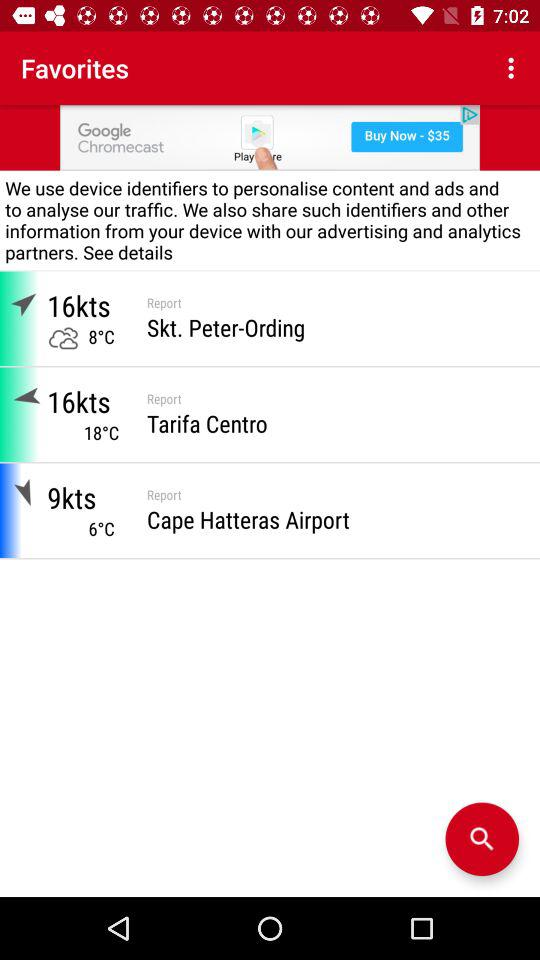What is the temperature in Tarifa Centro? The temperature in Tarifa Centro is 18 °C. 